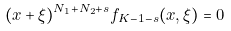<formula> <loc_0><loc_0><loc_500><loc_500>( x + \xi ) ^ { N _ { 1 } + N _ { 2 } + s } f _ { K - 1 - s } ( x , \xi ) = 0</formula> 